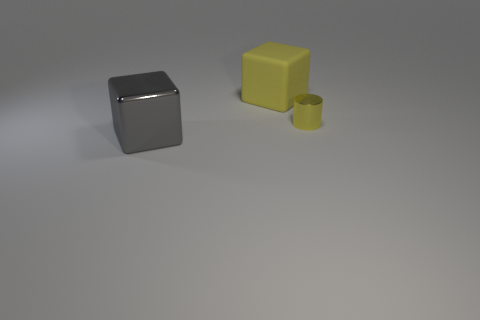How many things are yellow blocks or small shiny things? In the image, there is one yellow block and one small shiny object, which is a silver cube, making a total of two items that fit the description. 